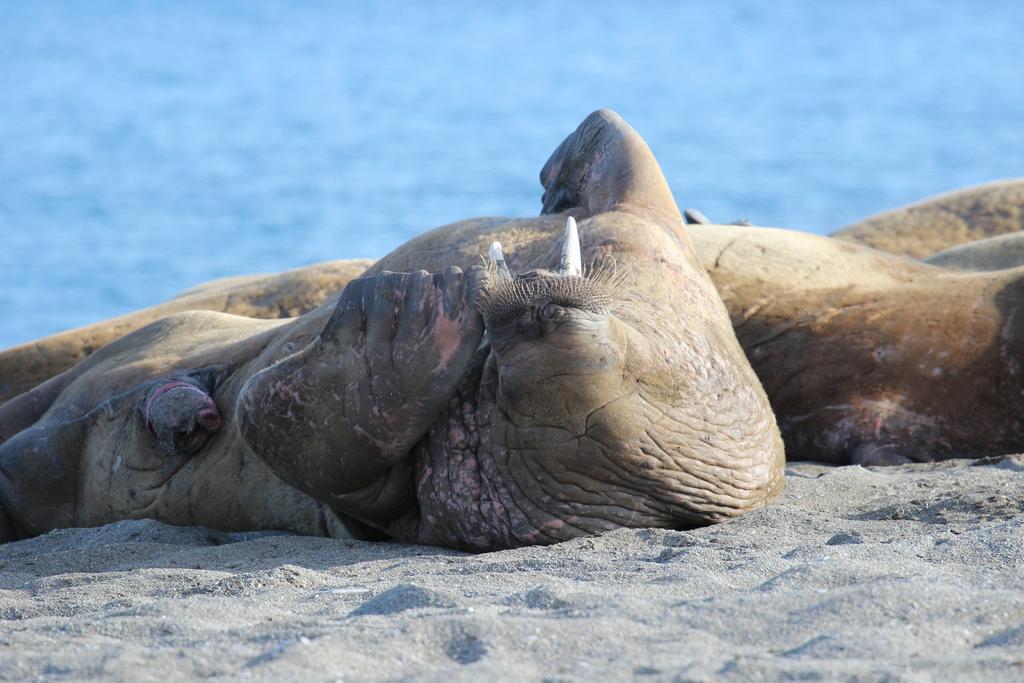Please provide a concise description of this image. In this image there are animals, soil and water. 